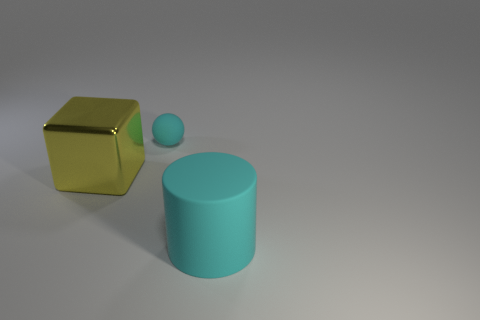Are there fewer small brown cylinders than rubber spheres?
Provide a succinct answer. Yes. What shape is the rubber thing behind the thing that is right of the cyan object that is behind the large matte cylinder?
Offer a very short reply. Sphere. Are there any red cylinders made of the same material as the cyan cylinder?
Offer a very short reply. No. Do the rubber object in front of the yellow metallic block and the rubber object that is behind the large cylinder have the same color?
Offer a terse response. Yes. Are there fewer big yellow cubes that are behind the big cyan cylinder than cyan matte objects?
Provide a succinct answer. Yes. What number of things are either tiny red rubber objects or objects right of the metallic object?
Your response must be concise. 2. There is a cylinder that is made of the same material as the tiny thing; what is its color?
Give a very brief answer. Cyan. How many objects are shiny blocks or small spheres?
Make the answer very short. 2. What color is the matte object that is the same size as the cube?
Offer a very short reply. Cyan. How many objects are cyan things behind the cyan cylinder or blue rubber objects?
Your response must be concise. 1. 